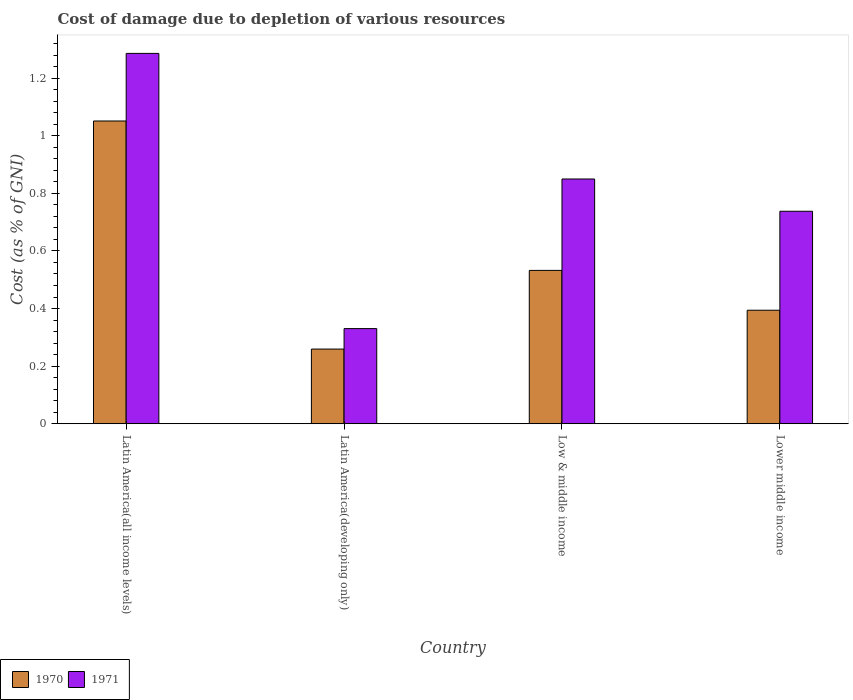How many bars are there on the 3rd tick from the left?
Give a very brief answer. 2. What is the label of the 1st group of bars from the left?
Ensure brevity in your answer.  Latin America(all income levels). In how many cases, is the number of bars for a given country not equal to the number of legend labels?
Your answer should be very brief. 0. What is the cost of damage caused due to the depletion of various resources in 1971 in Low & middle income?
Keep it short and to the point. 0.85. Across all countries, what is the maximum cost of damage caused due to the depletion of various resources in 1970?
Ensure brevity in your answer.  1.05. Across all countries, what is the minimum cost of damage caused due to the depletion of various resources in 1971?
Offer a terse response. 0.33. In which country was the cost of damage caused due to the depletion of various resources in 1970 maximum?
Your response must be concise. Latin America(all income levels). In which country was the cost of damage caused due to the depletion of various resources in 1971 minimum?
Your answer should be very brief. Latin America(developing only). What is the total cost of damage caused due to the depletion of various resources in 1971 in the graph?
Your answer should be very brief. 3.2. What is the difference between the cost of damage caused due to the depletion of various resources in 1970 in Latin America(all income levels) and that in Low & middle income?
Your answer should be very brief. 0.52. What is the difference between the cost of damage caused due to the depletion of various resources in 1970 in Latin America(developing only) and the cost of damage caused due to the depletion of various resources in 1971 in Low & middle income?
Provide a succinct answer. -0.59. What is the average cost of damage caused due to the depletion of various resources in 1970 per country?
Give a very brief answer. 0.56. What is the difference between the cost of damage caused due to the depletion of various resources of/in 1971 and cost of damage caused due to the depletion of various resources of/in 1970 in Latin America(developing only)?
Offer a terse response. 0.07. In how many countries, is the cost of damage caused due to the depletion of various resources in 1971 greater than 1.2800000000000002 %?
Offer a terse response. 1. What is the ratio of the cost of damage caused due to the depletion of various resources in 1971 in Latin America(all income levels) to that in Latin America(developing only)?
Provide a short and direct response. 3.89. What is the difference between the highest and the second highest cost of damage caused due to the depletion of various resources in 1971?
Offer a terse response. -0.44. What is the difference between the highest and the lowest cost of damage caused due to the depletion of various resources in 1970?
Offer a terse response. 0.79. In how many countries, is the cost of damage caused due to the depletion of various resources in 1971 greater than the average cost of damage caused due to the depletion of various resources in 1971 taken over all countries?
Give a very brief answer. 2. What does the 1st bar from the left in Low & middle income represents?
Your response must be concise. 1970. What does the 2nd bar from the right in Lower middle income represents?
Make the answer very short. 1970. How many countries are there in the graph?
Make the answer very short. 4. Are the values on the major ticks of Y-axis written in scientific E-notation?
Ensure brevity in your answer.  No. Does the graph contain any zero values?
Give a very brief answer. No. How many legend labels are there?
Keep it short and to the point. 2. What is the title of the graph?
Your response must be concise. Cost of damage due to depletion of various resources. Does "2009" appear as one of the legend labels in the graph?
Make the answer very short. No. What is the label or title of the X-axis?
Offer a terse response. Country. What is the label or title of the Y-axis?
Provide a short and direct response. Cost (as % of GNI). What is the Cost (as % of GNI) of 1970 in Latin America(all income levels)?
Ensure brevity in your answer.  1.05. What is the Cost (as % of GNI) in 1971 in Latin America(all income levels)?
Provide a short and direct response. 1.29. What is the Cost (as % of GNI) of 1970 in Latin America(developing only)?
Your answer should be compact. 0.26. What is the Cost (as % of GNI) of 1971 in Latin America(developing only)?
Make the answer very short. 0.33. What is the Cost (as % of GNI) of 1970 in Low & middle income?
Offer a very short reply. 0.53. What is the Cost (as % of GNI) in 1971 in Low & middle income?
Offer a very short reply. 0.85. What is the Cost (as % of GNI) in 1970 in Lower middle income?
Offer a terse response. 0.39. What is the Cost (as % of GNI) in 1971 in Lower middle income?
Make the answer very short. 0.74. Across all countries, what is the maximum Cost (as % of GNI) of 1970?
Your answer should be very brief. 1.05. Across all countries, what is the maximum Cost (as % of GNI) in 1971?
Your answer should be compact. 1.29. Across all countries, what is the minimum Cost (as % of GNI) in 1970?
Your answer should be compact. 0.26. Across all countries, what is the minimum Cost (as % of GNI) of 1971?
Keep it short and to the point. 0.33. What is the total Cost (as % of GNI) of 1970 in the graph?
Provide a succinct answer. 2.24. What is the total Cost (as % of GNI) in 1971 in the graph?
Offer a very short reply. 3.2. What is the difference between the Cost (as % of GNI) in 1970 in Latin America(all income levels) and that in Latin America(developing only)?
Your response must be concise. 0.79. What is the difference between the Cost (as % of GNI) in 1971 in Latin America(all income levels) and that in Latin America(developing only)?
Make the answer very short. 0.96. What is the difference between the Cost (as % of GNI) of 1970 in Latin America(all income levels) and that in Low & middle income?
Your answer should be compact. 0.52. What is the difference between the Cost (as % of GNI) in 1971 in Latin America(all income levels) and that in Low & middle income?
Your answer should be compact. 0.44. What is the difference between the Cost (as % of GNI) of 1970 in Latin America(all income levels) and that in Lower middle income?
Offer a very short reply. 0.66. What is the difference between the Cost (as % of GNI) of 1971 in Latin America(all income levels) and that in Lower middle income?
Your answer should be very brief. 0.55. What is the difference between the Cost (as % of GNI) in 1970 in Latin America(developing only) and that in Low & middle income?
Provide a succinct answer. -0.27. What is the difference between the Cost (as % of GNI) of 1971 in Latin America(developing only) and that in Low & middle income?
Offer a terse response. -0.52. What is the difference between the Cost (as % of GNI) of 1970 in Latin America(developing only) and that in Lower middle income?
Your answer should be compact. -0.13. What is the difference between the Cost (as % of GNI) in 1971 in Latin America(developing only) and that in Lower middle income?
Make the answer very short. -0.41. What is the difference between the Cost (as % of GNI) of 1970 in Low & middle income and that in Lower middle income?
Your response must be concise. 0.14. What is the difference between the Cost (as % of GNI) in 1971 in Low & middle income and that in Lower middle income?
Provide a succinct answer. 0.11. What is the difference between the Cost (as % of GNI) in 1970 in Latin America(all income levels) and the Cost (as % of GNI) in 1971 in Latin America(developing only)?
Offer a terse response. 0.72. What is the difference between the Cost (as % of GNI) of 1970 in Latin America(all income levels) and the Cost (as % of GNI) of 1971 in Low & middle income?
Provide a succinct answer. 0.2. What is the difference between the Cost (as % of GNI) of 1970 in Latin America(all income levels) and the Cost (as % of GNI) of 1971 in Lower middle income?
Make the answer very short. 0.31. What is the difference between the Cost (as % of GNI) of 1970 in Latin America(developing only) and the Cost (as % of GNI) of 1971 in Low & middle income?
Provide a short and direct response. -0.59. What is the difference between the Cost (as % of GNI) of 1970 in Latin America(developing only) and the Cost (as % of GNI) of 1971 in Lower middle income?
Offer a terse response. -0.48. What is the difference between the Cost (as % of GNI) of 1970 in Low & middle income and the Cost (as % of GNI) of 1971 in Lower middle income?
Offer a very short reply. -0.21. What is the average Cost (as % of GNI) in 1970 per country?
Offer a terse response. 0.56. What is the average Cost (as % of GNI) of 1971 per country?
Your response must be concise. 0.8. What is the difference between the Cost (as % of GNI) in 1970 and Cost (as % of GNI) in 1971 in Latin America(all income levels)?
Give a very brief answer. -0.23. What is the difference between the Cost (as % of GNI) in 1970 and Cost (as % of GNI) in 1971 in Latin America(developing only)?
Provide a short and direct response. -0.07. What is the difference between the Cost (as % of GNI) of 1970 and Cost (as % of GNI) of 1971 in Low & middle income?
Provide a succinct answer. -0.32. What is the difference between the Cost (as % of GNI) in 1970 and Cost (as % of GNI) in 1971 in Lower middle income?
Offer a terse response. -0.34. What is the ratio of the Cost (as % of GNI) in 1970 in Latin America(all income levels) to that in Latin America(developing only)?
Your answer should be very brief. 4.05. What is the ratio of the Cost (as % of GNI) in 1971 in Latin America(all income levels) to that in Latin America(developing only)?
Provide a succinct answer. 3.89. What is the ratio of the Cost (as % of GNI) in 1970 in Latin America(all income levels) to that in Low & middle income?
Your answer should be compact. 1.97. What is the ratio of the Cost (as % of GNI) of 1971 in Latin America(all income levels) to that in Low & middle income?
Your answer should be compact. 1.51. What is the ratio of the Cost (as % of GNI) of 1970 in Latin America(all income levels) to that in Lower middle income?
Your answer should be compact. 2.67. What is the ratio of the Cost (as % of GNI) of 1971 in Latin America(all income levels) to that in Lower middle income?
Make the answer very short. 1.74. What is the ratio of the Cost (as % of GNI) in 1970 in Latin America(developing only) to that in Low & middle income?
Your answer should be very brief. 0.49. What is the ratio of the Cost (as % of GNI) in 1971 in Latin America(developing only) to that in Low & middle income?
Offer a terse response. 0.39. What is the ratio of the Cost (as % of GNI) of 1970 in Latin America(developing only) to that in Lower middle income?
Your response must be concise. 0.66. What is the ratio of the Cost (as % of GNI) of 1971 in Latin America(developing only) to that in Lower middle income?
Offer a terse response. 0.45. What is the ratio of the Cost (as % of GNI) in 1970 in Low & middle income to that in Lower middle income?
Your answer should be compact. 1.35. What is the ratio of the Cost (as % of GNI) of 1971 in Low & middle income to that in Lower middle income?
Offer a terse response. 1.15. What is the difference between the highest and the second highest Cost (as % of GNI) of 1970?
Offer a very short reply. 0.52. What is the difference between the highest and the second highest Cost (as % of GNI) of 1971?
Provide a short and direct response. 0.44. What is the difference between the highest and the lowest Cost (as % of GNI) in 1970?
Make the answer very short. 0.79. What is the difference between the highest and the lowest Cost (as % of GNI) in 1971?
Keep it short and to the point. 0.96. 